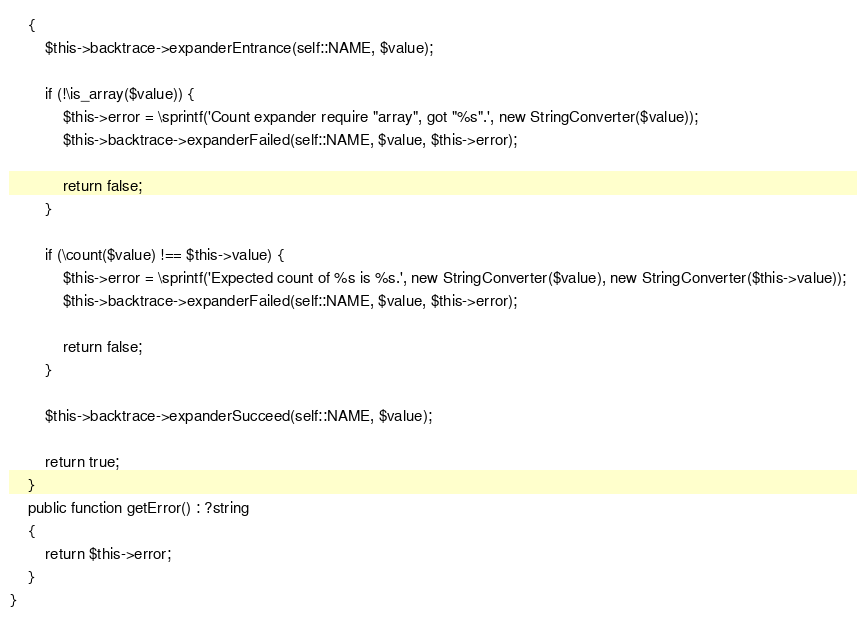<code> <loc_0><loc_0><loc_500><loc_500><_PHP_>    {
        $this->backtrace->expanderEntrance(self::NAME, $value);

        if (!\is_array($value)) {
            $this->error = \sprintf('Count expander require "array", got "%s".', new StringConverter($value));
            $this->backtrace->expanderFailed(self::NAME, $value, $this->error);

            return false;
        }

        if (\count($value) !== $this->value) {
            $this->error = \sprintf('Expected count of %s is %s.', new StringConverter($value), new StringConverter($this->value));
            $this->backtrace->expanderFailed(self::NAME, $value, $this->error);

            return false;
        }

        $this->backtrace->expanderSucceed(self::NAME, $value);

        return true;
    }
    public function getError() : ?string
    {
        return $this->error;
    }
}
</code> 